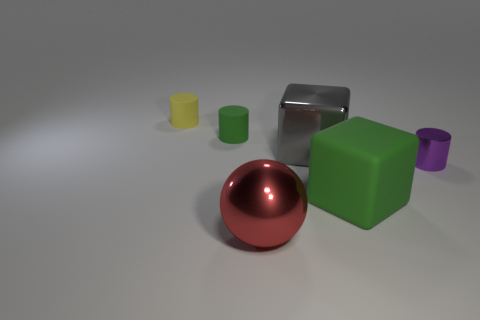Subtract all matte cylinders. How many cylinders are left? 1 Add 1 big metallic cylinders. How many objects exist? 7 Subtract all green objects. Subtract all big gray cylinders. How many objects are left? 4 Add 2 tiny yellow matte objects. How many tiny yellow matte objects are left? 3 Add 5 small purple spheres. How many small purple spheres exist? 5 Subtract 1 purple cylinders. How many objects are left? 5 Subtract all balls. How many objects are left? 5 